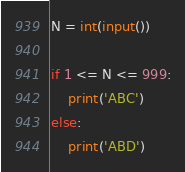Convert code to text. <code><loc_0><loc_0><loc_500><loc_500><_Python_>N = int(input())

if 1 <= N <= 999:
    print('ABC')
else:
    print('ABD')</code> 